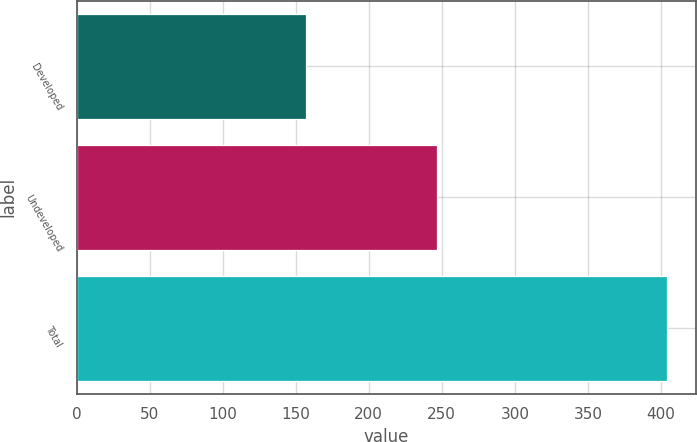Convert chart to OTSL. <chart><loc_0><loc_0><loc_500><loc_500><bar_chart><fcel>Developed<fcel>Undeveloped<fcel>Total<nl><fcel>157<fcel>247<fcel>404<nl></chart> 